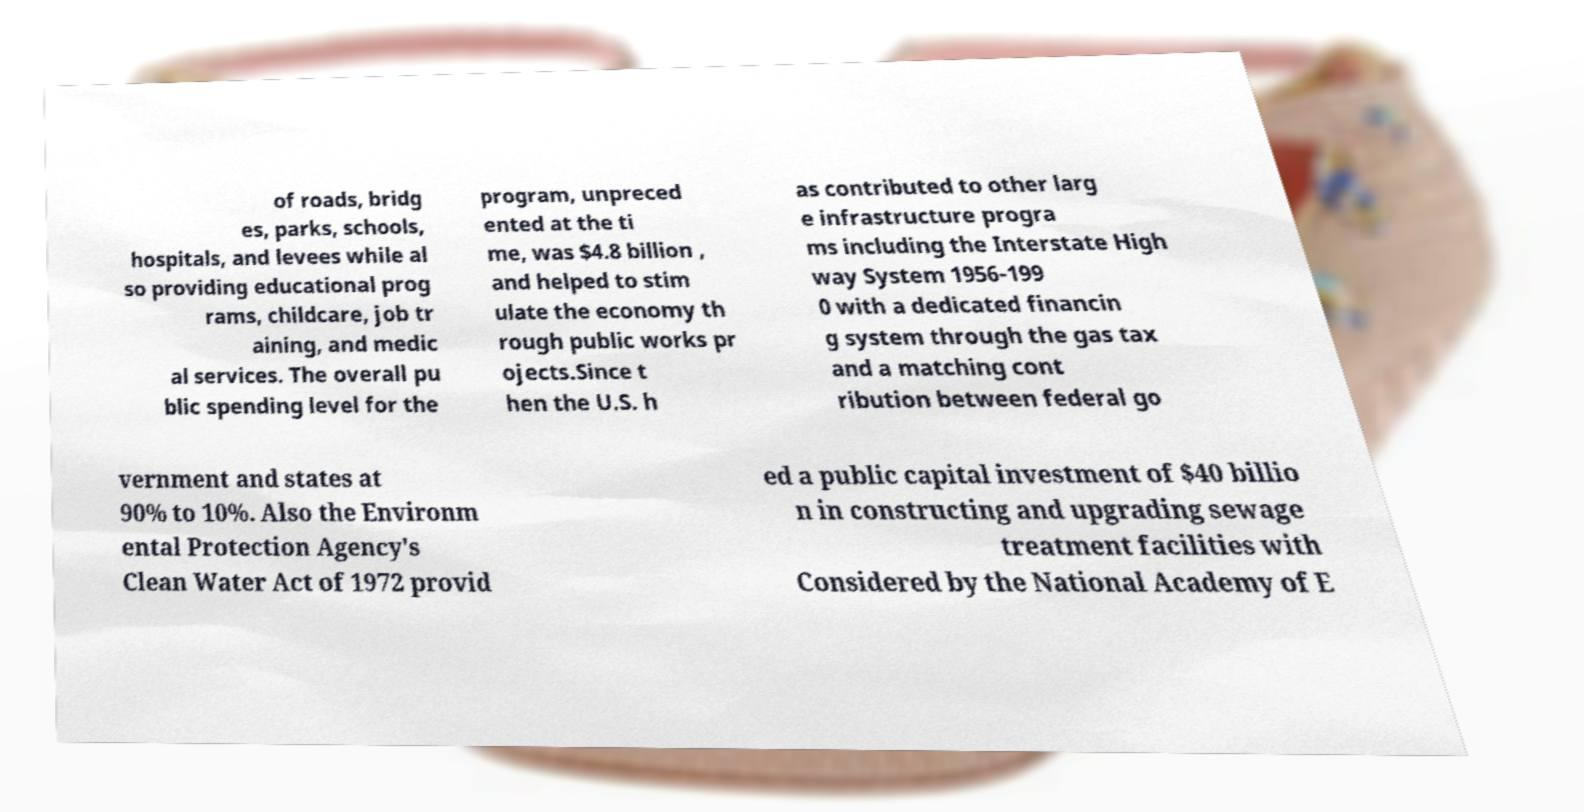Can you read and provide the text displayed in the image?This photo seems to have some interesting text. Can you extract and type it out for me? of roads, bridg es, parks, schools, hospitals, and levees while al so providing educational prog rams, childcare, job tr aining, and medic al services. The overall pu blic spending level for the program, unpreced ented at the ti me, was $4.8 billion , and helped to stim ulate the economy th rough public works pr ojects.Since t hen the U.S. h as contributed to other larg e infrastructure progra ms including the Interstate High way System 1956-199 0 with a dedicated financin g system through the gas tax and a matching cont ribution between federal go vernment and states at 90% to 10%. Also the Environm ental Protection Agency's Clean Water Act of 1972 provid ed a public capital investment of $40 billio n in constructing and upgrading sewage treatment facilities with Considered by the National Academy of E 